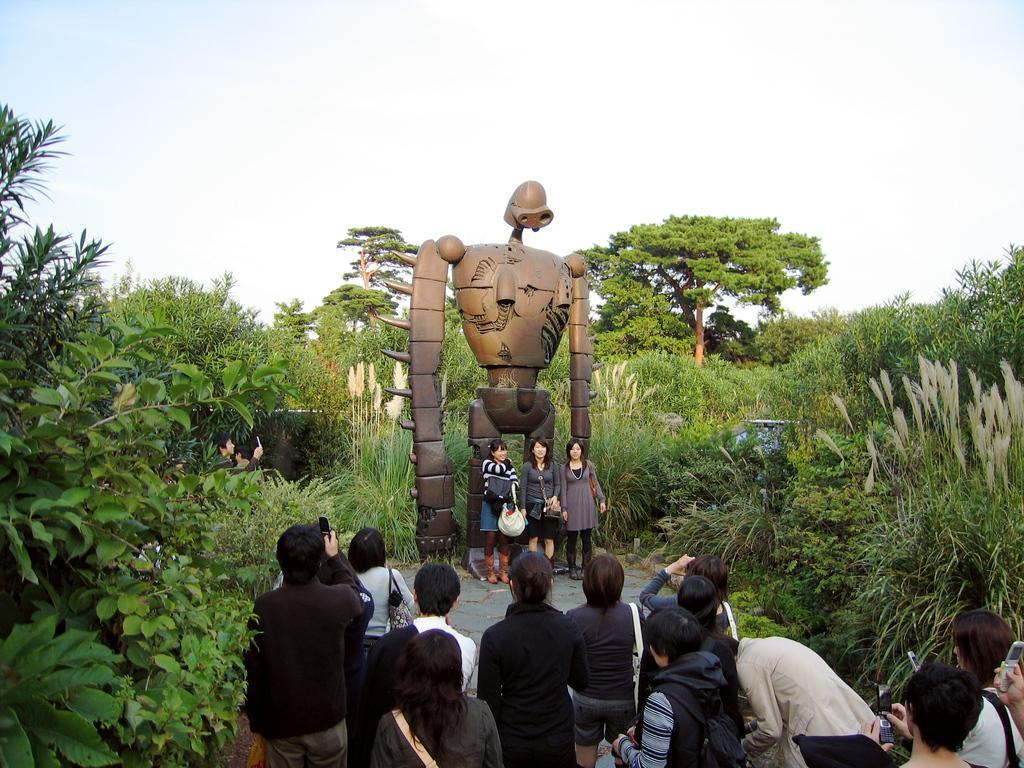Could you give a brief overview of what you see in this image? This image consists of many people. In the front, there is a statue. It looks like a robot. To the left and right, there are plants. In the background, there are many trees. 